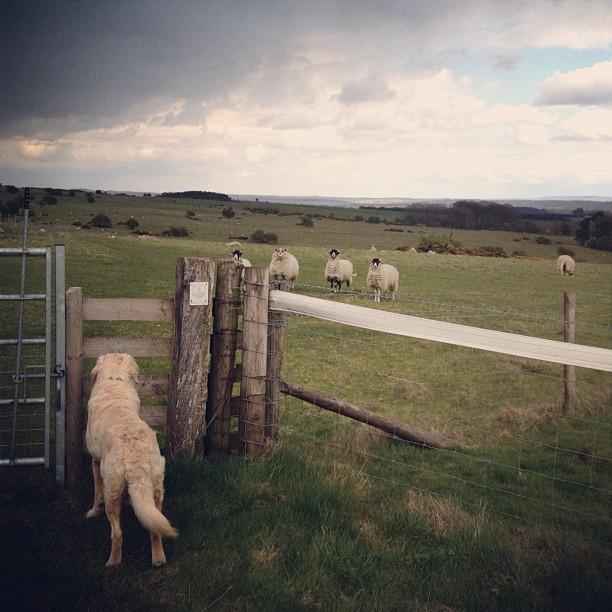What is this dog trying to catch?
Be succinct. Sheep. Is the gate closed in this picture?
Quick response, please. Yes. What breed of dogs are these?
Concise answer only. Retriever. Does the dog have short hair?
Keep it brief. Yes. What kind of animal is shown?
Be succinct. Dog. How many dogs?
Be succinct. 1. Is this animal real or fake?
Be succinct. Real. How are these animals related?
Concise answer only. Sibling. How many sheep are in the field?
Short answer required. 5. Is this dog on a bench?
Keep it brief. No. Is there any hay in the picture?
Be succinct. No. What is the dog looking at?
Write a very short answer. Sheep. What color is the animal on the right's fur?
Quick response, please. White. How many dogs are lying down?
Answer briefly. 0. What breed is the dog?
Be succinct. Golden retriever. What is the gate made of?
Give a very brief answer. Metal. What type of animal is pictured?
Concise answer only. Dog and sheep. 